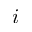Convert formula to latex. <formula><loc_0><loc_0><loc_500><loc_500>i</formula> 